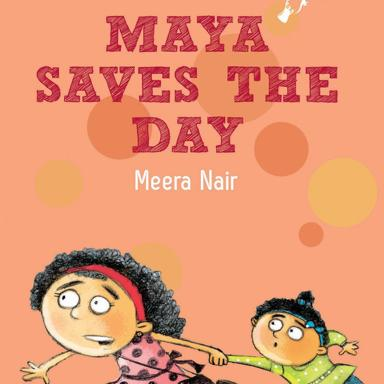What is the title and author of the children's book mentioned in the image? The children's book featured in the image has the title 'Maya Saves The Day,' authored by Meera Nair. The book cover boasts vibrant colors and whimsical illustrations, captivating the essence of a children's story that promises adventure and excitement. 